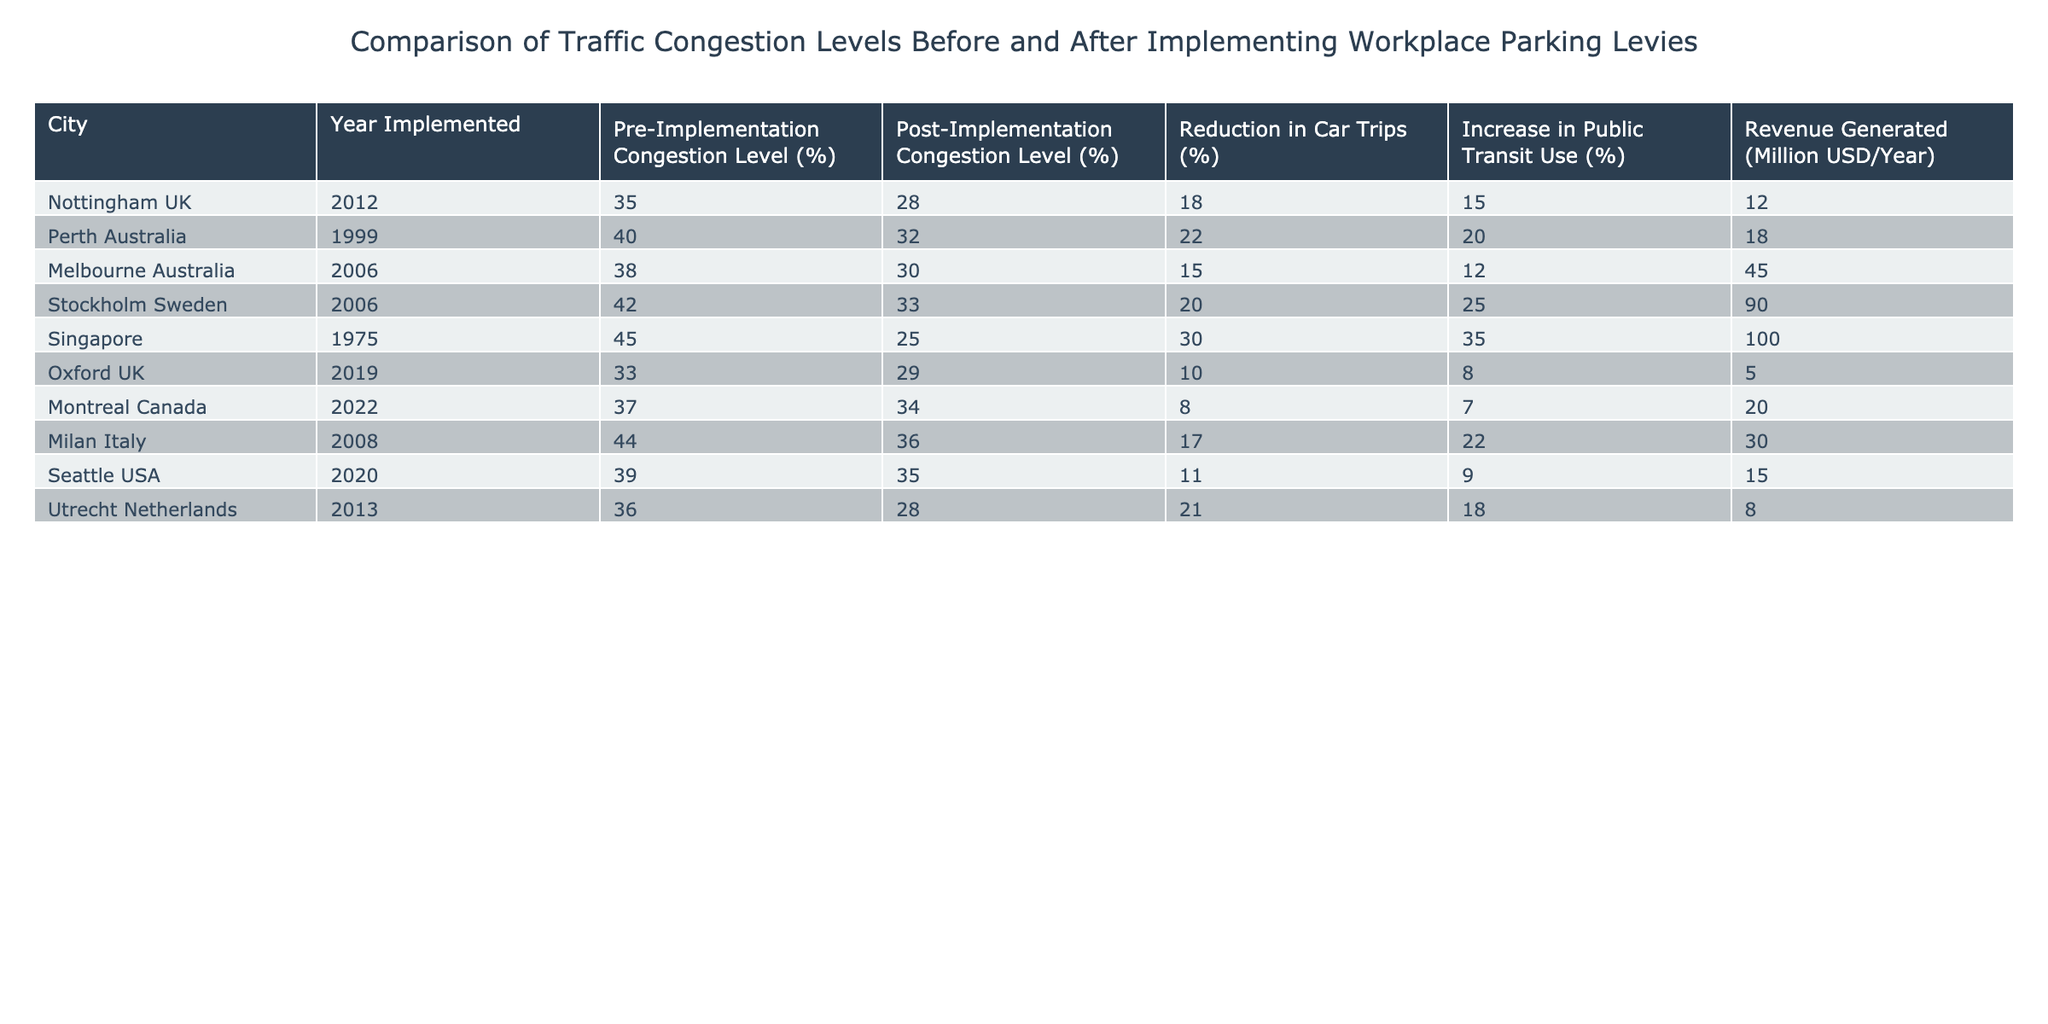What city had the highest pre-implementation congestion level? Looking at the table, Singapore had the highest pre-implementation congestion level at 45%.
Answer: 45% What is the average reduction in car trips across all cities? To find the average, we add the reduction percentages: 18 + 22 + 15 + 20 + 30 + 10 + 8 + 17 + 11 + 21 =  182. Then, we divide by the number of cities (10): 182 / 10 = 18.2%.
Answer: 18.2% Did all cities experience a reduction in congestion levels after implementing the workplace parking levy? By reviewing the table, we see that all listed cities show a decrease in congestion levels from the pre-implementation to post-implementation data.
Answer: Yes Which city had the lowest revenue generated from the workplace parking levy? When comparing the revenue generated (in million USD/year), Oxford UK has the lowest at 5 million USD.
Answer: 5 million USD What was the percentage increase in public transit use for Stockholm Sweden? In the table, Stockholm Sweden shows an increase in public transit use of 25%. Therefore, the answer is found directly by referencing the value in the table.
Answer: 25% Which city had the largest percentage reduction in congestion levels? To determine this, we subtract post-implementation levels from pre-implementation levels. For Singapore, that is (45% - 25%) = 20%. Stockholm, however, also has (42% - 33%) = 9%. The largest reduction is therefore for Singapore at 20%.
Answer: 20% Is there a correlation between the reduction in car trips and the increase in public transit use? Examining the table shows varying values: for example, Singapore has the highest reduction in car trips (30%) and a corresponding increase in public transit use (35%), while Montreal has a lower reduction (8%) and a lower increase (7%). While one trend can be spotted that higher reductions often accompany higher public transit use, it is not consistent across all cases.
Answer: No What is the median revenue generated from the workplace parking levy among the cities? Ordering the revenues from least to greatest: 5, 12, 15, 18, 20, 30, 45, 90, 100. With 10 data points, the median is the average of the 5th and 6th values: (20 + 30) / 2 = 25 million USD.
Answer: 25 million USD 